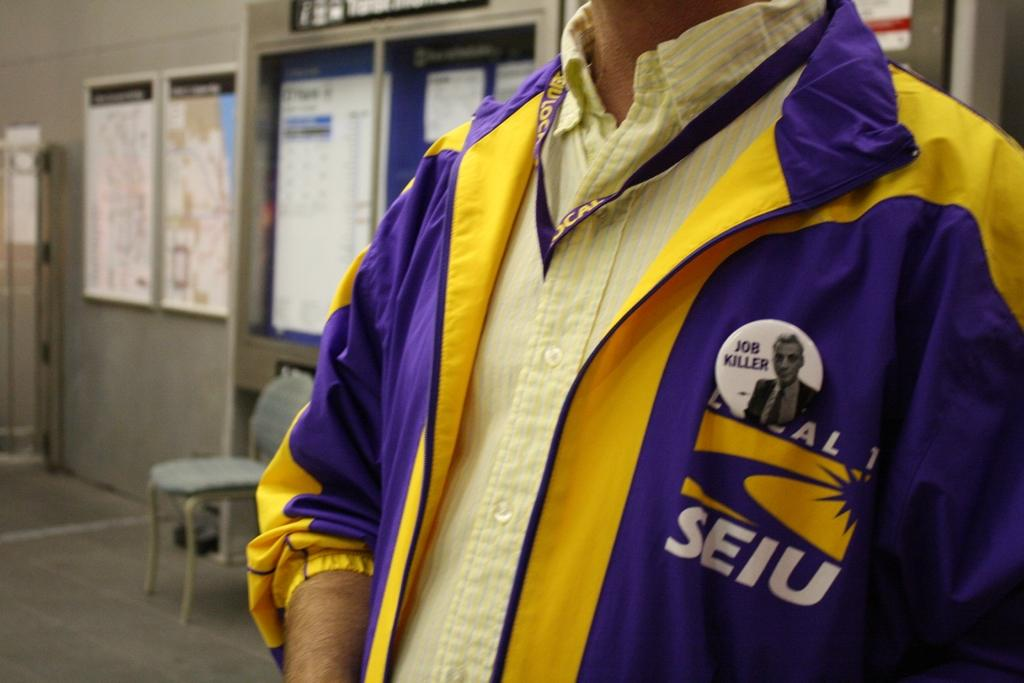Provide a one-sentence caption for the provided image. A man wearing a purple and yellow jacket with the logo SEIU. 